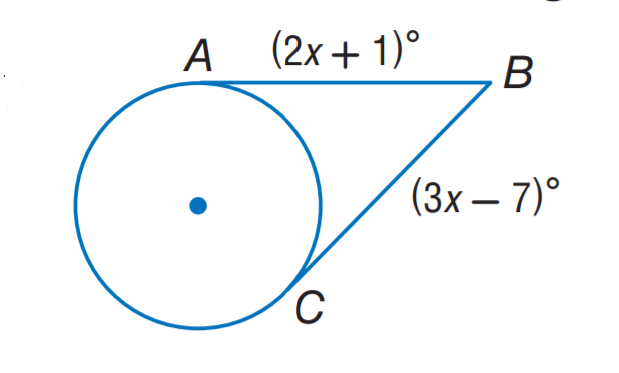Question: The segment is tangent to the circle. Find x.
Choices:
A. 6
B. 7
C. 8
D. 9
Answer with the letter. Answer: C 